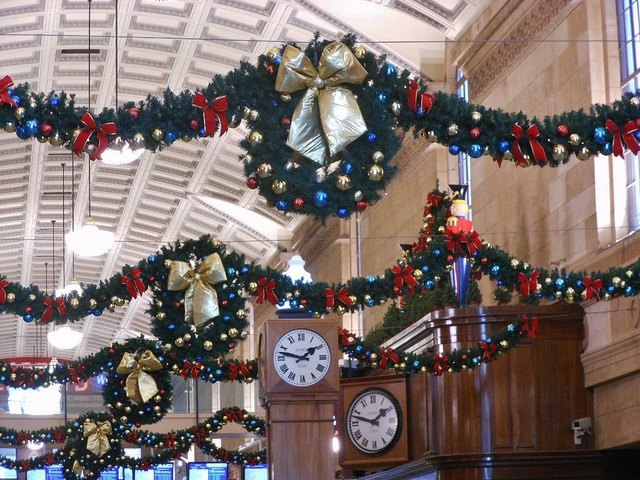Describe the objects in this image and their specific colors. I can see clock in lightgray, darkgray, and gray tones and clock in lightgray, darkgray, gray, and black tones in this image. 